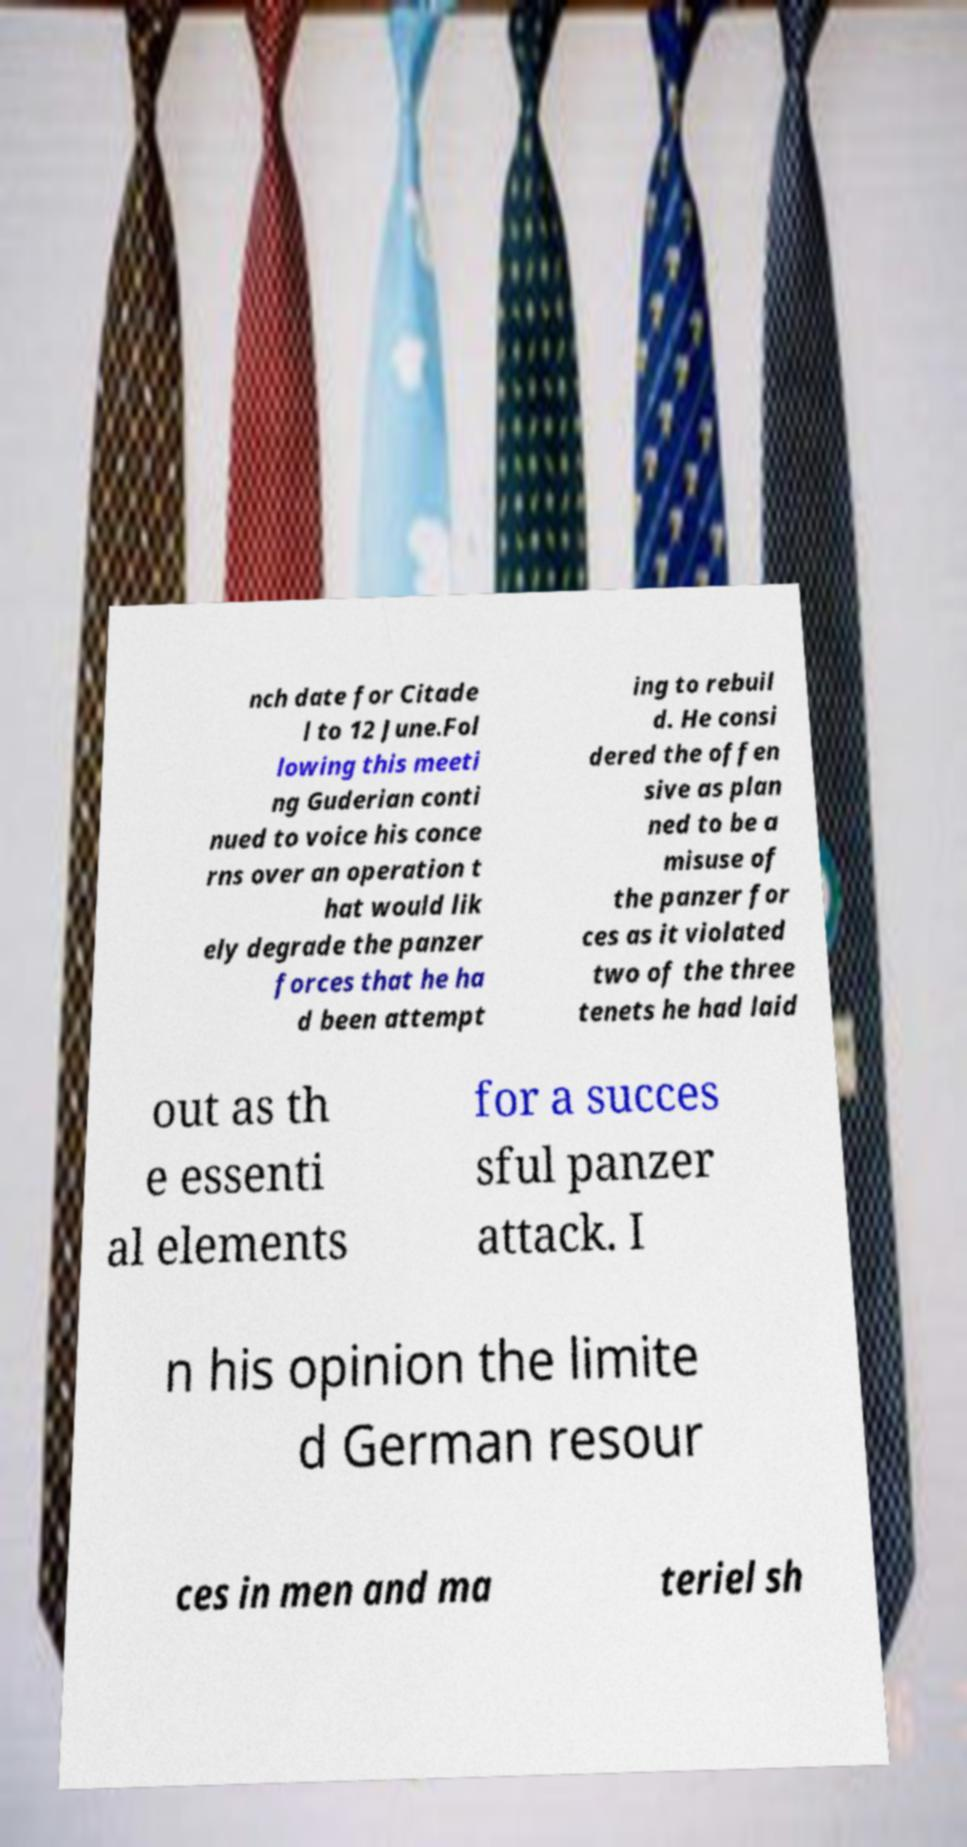I need the written content from this picture converted into text. Can you do that? nch date for Citade l to 12 June.Fol lowing this meeti ng Guderian conti nued to voice his conce rns over an operation t hat would lik ely degrade the panzer forces that he ha d been attempt ing to rebuil d. He consi dered the offen sive as plan ned to be a misuse of the panzer for ces as it violated two of the three tenets he had laid out as th e essenti al elements for a succes sful panzer attack. I n his opinion the limite d German resour ces in men and ma teriel sh 